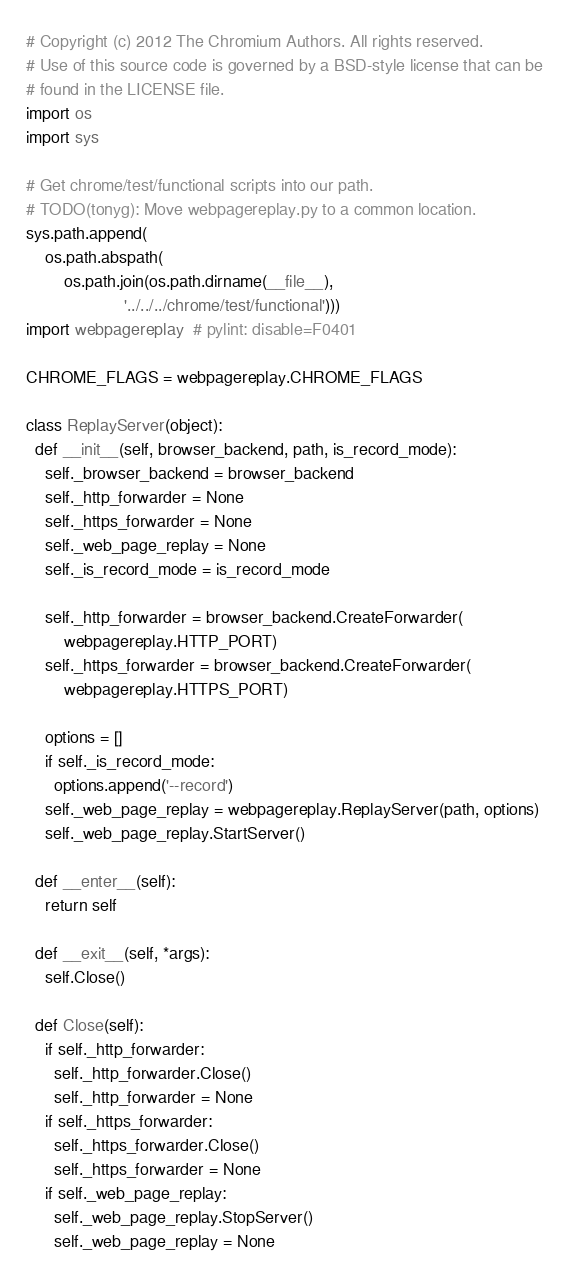<code> <loc_0><loc_0><loc_500><loc_500><_Python_># Copyright (c) 2012 The Chromium Authors. All rights reserved.
# Use of this source code is governed by a BSD-style license that can be
# found in the LICENSE file.
import os
import sys

# Get chrome/test/functional scripts into our path.
# TODO(tonyg): Move webpagereplay.py to a common location.
sys.path.append(
    os.path.abspath(
        os.path.join(os.path.dirname(__file__),
                     '../../../chrome/test/functional')))
import webpagereplay  # pylint: disable=F0401

CHROME_FLAGS = webpagereplay.CHROME_FLAGS

class ReplayServer(object):
  def __init__(self, browser_backend, path, is_record_mode):
    self._browser_backend = browser_backend
    self._http_forwarder = None
    self._https_forwarder = None
    self._web_page_replay = None
    self._is_record_mode = is_record_mode

    self._http_forwarder = browser_backend.CreateForwarder(
        webpagereplay.HTTP_PORT)
    self._https_forwarder = browser_backend.CreateForwarder(
        webpagereplay.HTTPS_PORT)

    options = []
    if self._is_record_mode:
      options.append('--record')
    self._web_page_replay = webpagereplay.ReplayServer(path, options)
    self._web_page_replay.StartServer()

  def __enter__(self):
    return self

  def __exit__(self, *args):
    self.Close()

  def Close(self):
    if self._http_forwarder:
      self._http_forwarder.Close()
      self._http_forwarder = None
    if self._https_forwarder:
      self._https_forwarder.Close()
      self._https_forwarder = None
    if self._web_page_replay:
      self._web_page_replay.StopServer()
      self._web_page_replay = None
</code> 